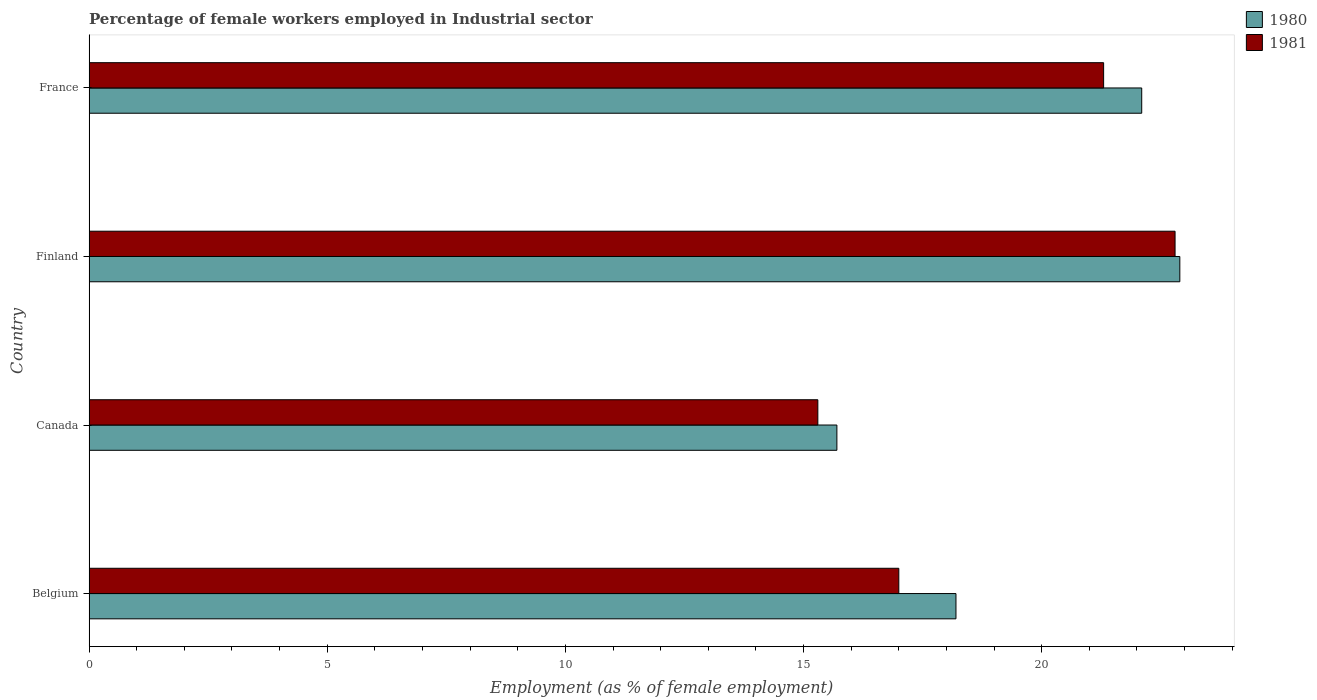How many different coloured bars are there?
Offer a terse response. 2. How many groups of bars are there?
Offer a very short reply. 4. What is the label of the 3rd group of bars from the top?
Your response must be concise. Canada. What is the percentage of females employed in Industrial sector in 1981 in Finland?
Your answer should be very brief. 22.8. Across all countries, what is the maximum percentage of females employed in Industrial sector in 1981?
Your response must be concise. 22.8. Across all countries, what is the minimum percentage of females employed in Industrial sector in 1980?
Offer a terse response. 15.7. What is the total percentage of females employed in Industrial sector in 1981 in the graph?
Your answer should be very brief. 76.4. What is the difference between the percentage of females employed in Industrial sector in 1980 in Belgium and that in Canada?
Give a very brief answer. 2.5. What is the difference between the percentage of females employed in Industrial sector in 1981 in Belgium and the percentage of females employed in Industrial sector in 1980 in Finland?
Your answer should be compact. -5.9. What is the average percentage of females employed in Industrial sector in 1981 per country?
Your answer should be compact. 19.1. What is the difference between the percentage of females employed in Industrial sector in 1981 and percentage of females employed in Industrial sector in 1980 in Finland?
Ensure brevity in your answer.  -0.1. What is the ratio of the percentage of females employed in Industrial sector in 1981 in Canada to that in France?
Provide a succinct answer. 0.72. Is the percentage of females employed in Industrial sector in 1981 in Canada less than that in Finland?
Offer a terse response. Yes. Is the difference between the percentage of females employed in Industrial sector in 1981 in Belgium and Finland greater than the difference between the percentage of females employed in Industrial sector in 1980 in Belgium and Finland?
Ensure brevity in your answer.  No. What is the difference between the highest and the second highest percentage of females employed in Industrial sector in 1980?
Your response must be concise. 0.8. What is the difference between the highest and the lowest percentage of females employed in Industrial sector in 1981?
Your response must be concise. 7.5. In how many countries, is the percentage of females employed in Industrial sector in 1981 greater than the average percentage of females employed in Industrial sector in 1981 taken over all countries?
Offer a very short reply. 2. Is the sum of the percentage of females employed in Industrial sector in 1981 in Finland and France greater than the maximum percentage of females employed in Industrial sector in 1980 across all countries?
Ensure brevity in your answer.  Yes. What does the 1st bar from the bottom in France represents?
Provide a short and direct response. 1980. How many bars are there?
Provide a succinct answer. 8. Are all the bars in the graph horizontal?
Keep it short and to the point. Yes. What is the difference between two consecutive major ticks on the X-axis?
Make the answer very short. 5. Are the values on the major ticks of X-axis written in scientific E-notation?
Provide a short and direct response. No. Does the graph contain any zero values?
Keep it short and to the point. No. Does the graph contain grids?
Give a very brief answer. No. How many legend labels are there?
Give a very brief answer. 2. What is the title of the graph?
Give a very brief answer. Percentage of female workers employed in Industrial sector. What is the label or title of the X-axis?
Ensure brevity in your answer.  Employment (as % of female employment). What is the Employment (as % of female employment) of 1980 in Belgium?
Ensure brevity in your answer.  18.2. What is the Employment (as % of female employment) in 1980 in Canada?
Your response must be concise. 15.7. What is the Employment (as % of female employment) in 1981 in Canada?
Your response must be concise. 15.3. What is the Employment (as % of female employment) in 1980 in Finland?
Your answer should be compact. 22.9. What is the Employment (as % of female employment) in 1981 in Finland?
Provide a succinct answer. 22.8. What is the Employment (as % of female employment) of 1980 in France?
Provide a succinct answer. 22.1. What is the Employment (as % of female employment) in 1981 in France?
Your answer should be compact. 21.3. Across all countries, what is the maximum Employment (as % of female employment) of 1980?
Your response must be concise. 22.9. Across all countries, what is the maximum Employment (as % of female employment) in 1981?
Offer a terse response. 22.8. Across all countries, what is the minimum Employment (as % of female employment) of 1980?
Your answer should be very brief. 15.7. Across all countries, what is the minimum Employment (as % of female employment) of 1981?
Your response must be concise. 15.3. What is the total Employment (as % of female employment) of 1980 in the graph?
Offer a terse response. 78.9. What is the total Employment (as % of female employment) in 1981 in the graph?
Your answer should be compact. 76.4. What is the difference between the Employment (as % of female employment) in 1981 in Belgium and that in Canada?
Offer a very short reply. 1.7. What is the difference between the Employment (as % of female employment) in 1980 in Belgium and that in France?
Offer a terse response. -3.9. What is the difference between the Employment (as % of female employment) of 1981 in Canada and that in Finland?
Offer a terse response. -7.5. What is the difference between the Employment (as % of female employment) in 1980 in Canada and the Employment (as % of female employment) in 1981 in Finland?
Your answer should be very brief. -7.1. What is the average Employment (as % of female employment) in 1980 per country?
Keep it short and to the point. 19.73. What is the difference between the Employment (as % of female employment) of 1980 and Employment (as % of female employment) of 1981 in Belgium?
Keep it short and to the point. 1.2. What is the ratio of the Employment (as % of female employment) of 1980 in Belgium to that in Canada?
Offer a very short reply. 1.16. What is the ratio of the Employment (as % of female employment) of 1980 in Belgium to that in Finland?
Ensure brevity in your answer.  0.79. What is the ratio of the Employment (as % of female employment) of 1981 in Belgium to that in Finland?
Ensure brevity in your answer.  0.75. What is the ratio of the Employment (as % of female employment) of 1980 in Belgium to that in France?
Make the answer very short. 0.82. What is the ratio of the Employment (as % of female employment) of 1981 in Belgium to that in France?
Your answer should be compact. 0.8. What is the ratio of the Employment (as % of female employment) in 1980 in Canada to that in Finland?
Your answer should be compact. 0.69. What is the ratio of the Employment (as % of female employment) of 1981 in Canada to that in Finland?
Offer a terse response. 0.67. What is the ratio of the Employment (as % of female employment) of 1980 in Canada to that in France?
Offer a terse response. 0.71. What is the ratio of the Employment (as % of female employment) of 1981 in Canada to that in France?
Your answer should be compact. 0.72. What is the ratio of the Employment (as % of female employment) of 1980 in Finland to that in France?
Ensure brevity in your answer.  1.04. What is the ratio of the Employment (as % of female employment) of 1981 in Finland to that in France?
Provide a short and direct response. 1.07. What is the difference between the highest and the second highest Employment (as % of female employment) of 1980?
Offer a terse response. 0.8. What is the difference between the highest and the second highest Employment (as % of female employment) in 1981?
Make the answer very short. 1.5. What is the difference between the highest and the lowest Employment (as % of female employment) in 1980?
Ensure brevity in your answer.  7.2. What is the difference between the highest and the lowest Employment (as % of female employment) of 1981?
Provide a succinct answer. 7.5. 